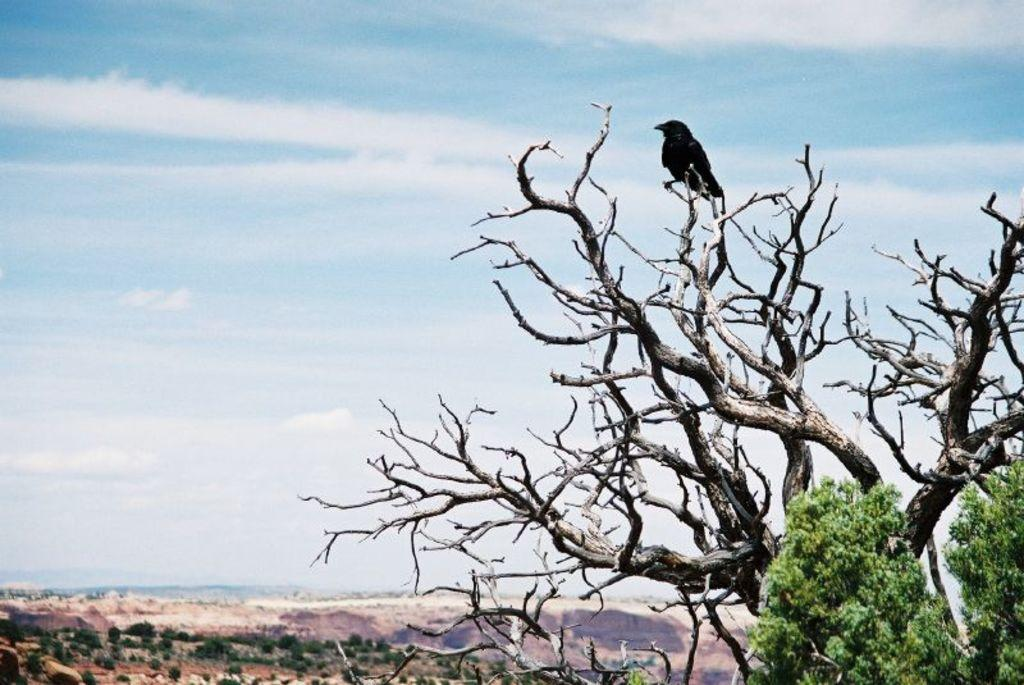What type of vegetation is on the right side of the image? There are trees on the right side of the image. Can you describe the bird in the image? There is a bird on one of the trees in the image. What is visible in the background of the image? The sky is visible in the background of the image. What can be seen in the sky? Clouds are present in the sky. What type of locket can be seen hanging from the bird's neck in the image? There is no locket present in the image; it features a bird on a tree with no additional accessories. How many fish are visible in the image? There are no fish present in the image; it features a bird on a tree and clouds in the sky. 